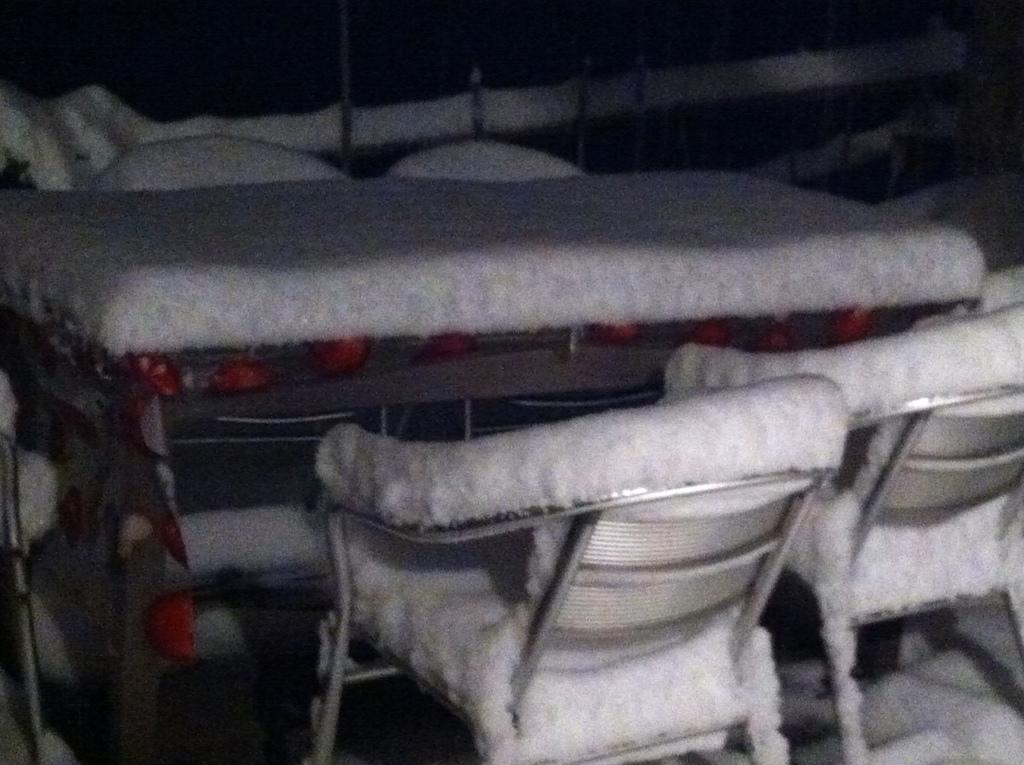What type of furniture is visible in the image? There is a table in the image. What is located on the ground near the table? There are chairs on the ground in the image. Can you describe any objects present in the image? Yes, there are objects present in the image. What is the color of the background in the image? The background of the image is dark. What type of ice can be seen melting on the table in the image? There is no ice present in the image; it only features a table, chairs, and objects. How many sacks are visible on the chairs in the image? There are no sacks visible on the chairs in the image. 